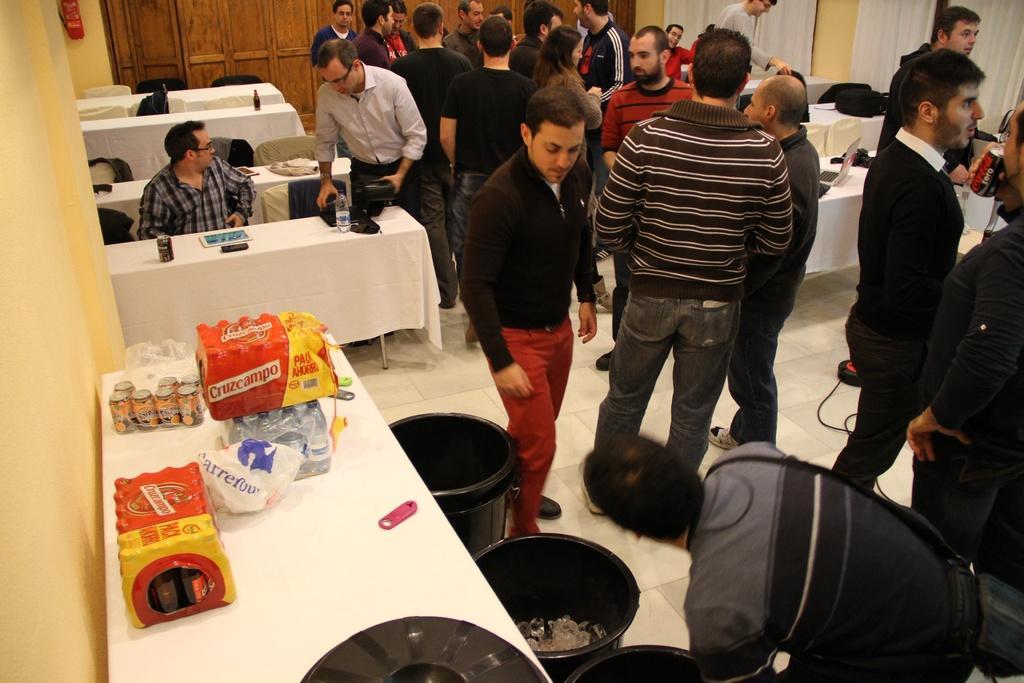In one or two sentences, can you explain what this image depicts? In this image we can see group of persons on the ground. On the left side of the image there are tables, chairs, tins and opener. In the background there are bags, tables, laptop, curtain and wall. 